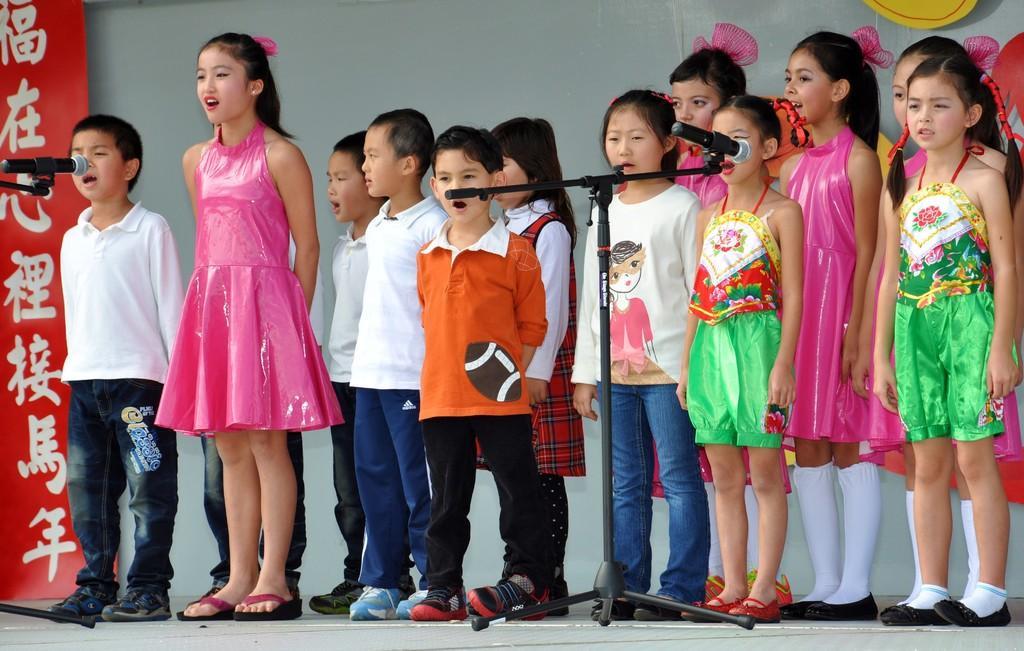What is happening in the image involving the group of people? There is a group of people standing in the image, but the specific activity cannot be determined from the provided facts. What objects are in front of the group of people? There are two microphones in front of the group. What is the color of the banner in the image? The banner in the image is red in color. What is the color of the background in the image? The background of the image is gray in color. What type of badge can be seen on the banner in the image? There is no badge present on the banner in the image; it is simply a red banner with no visible text or symbols. What word is written on the banner in the group is standing in front of? The provided facts do not mention any text or words on the banner, so we cannot determine what word might be written on it. 